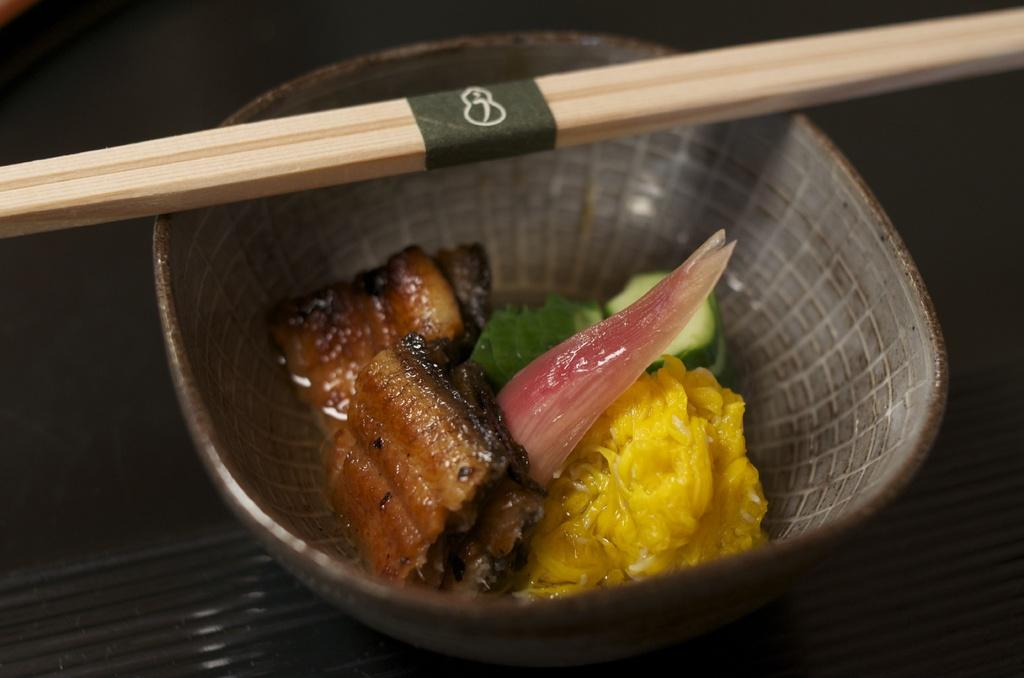What type of food can be seen in the image? The food in the image contains meat and vegetables. How is the food presented in the image? The food is in a bowl. What utensils are used with the food in the image? There are two sticks on the bowl. What is the growth rate of the silver in the image? There is no silver present in the image, so it is not possible to determine its growth rate. 